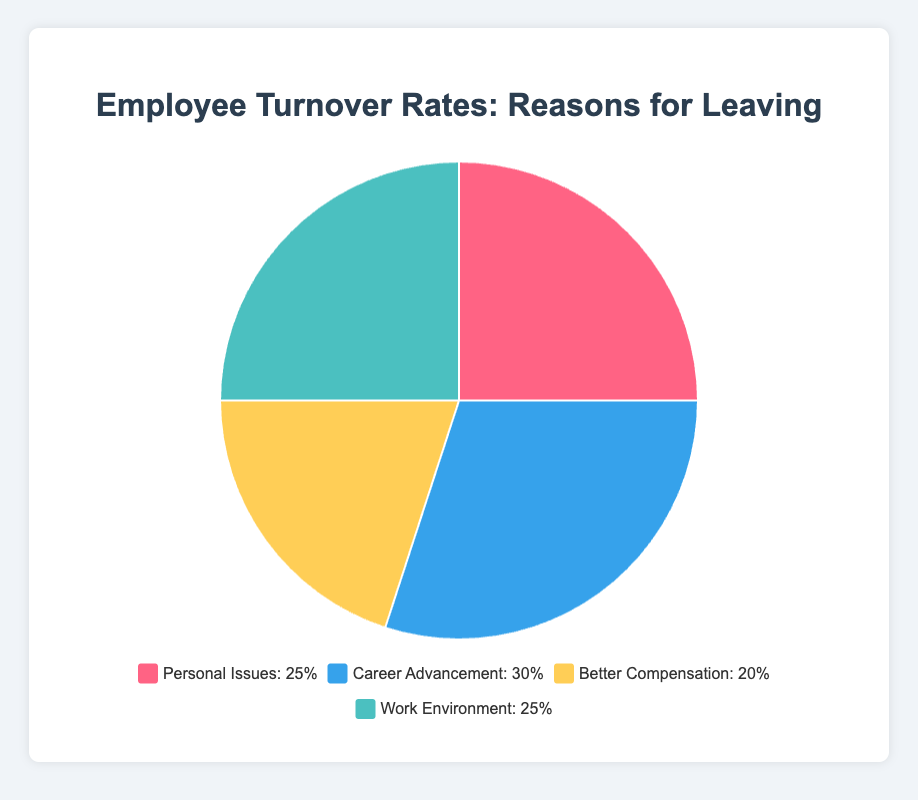What is the most common reason for employee turnover according to the pie chart? The segment representing Career Advancement is the largest, taking up 30% of the pie.
Answer: Career Advancement Which reasons for employee turnover are equally represented in the pie chart? Both Personal Issues and Work Environment segments each take up 25% of the pie chart.
Answer: Personal Issues and Work Environment What is the total percentage of employee turnover attributed to Career Advancement and Better Compensation? The percentage for Career Advancement is 30%, and for Better Compensation, it is 20%. Adding these two gives 30% + 20% = 50%.
Answer: 50% Are Personal Issues more significant than Better Compensation in terms of employee turnover? The pie chart shows Personal Issues at 25% and Better Compensation at 20%. Since 25% is greater than 20%, Personal Issues have a higher percentage.
Answer: Yes What color represents Better Compensation in the pie chart? The color used for Better Compensation is yellow, indicated in the legend and pie chart segment.
Answer: Yellow How does the percentage of employee turnover due to Work Environment compare to that of Personal Issues? Both Work Environment and Personal Issues each account for 25% of the employee turnover, making them equal in percentage.
Answer: They are equal If you combine the turnover reasons associated with job-related matters (Career Advancement and Work Environment), what is the resulting percentage? Career Advancement contributes 30% and Work Environment 25%. The combined percentage is 30% + 25% = 55%.
Answer: 55% Which reason for employee turnover has the second highest percentage in the pie chart? Based on the pie chart, Career Advancement is the highest at 30%. Both Personal Issues and Work Environment tie for the second highest at 25%.
Answer: Personal Issues and Work Environment What is the difference in employee turnover percentages between Personal Issues and Better Compensation? Personal Issues are at 25% and Better Compensation is at 20%. The difference is 25% - 20% = 5%.
Answer: 5% Identify the two turnover reasons that collectively make up half of the pie chart. Adding Career Advancement (30%) and Better Compensation (20%) together gives 30% + 20% = 50%.
Answer: Career Advancement and Better Compensation 